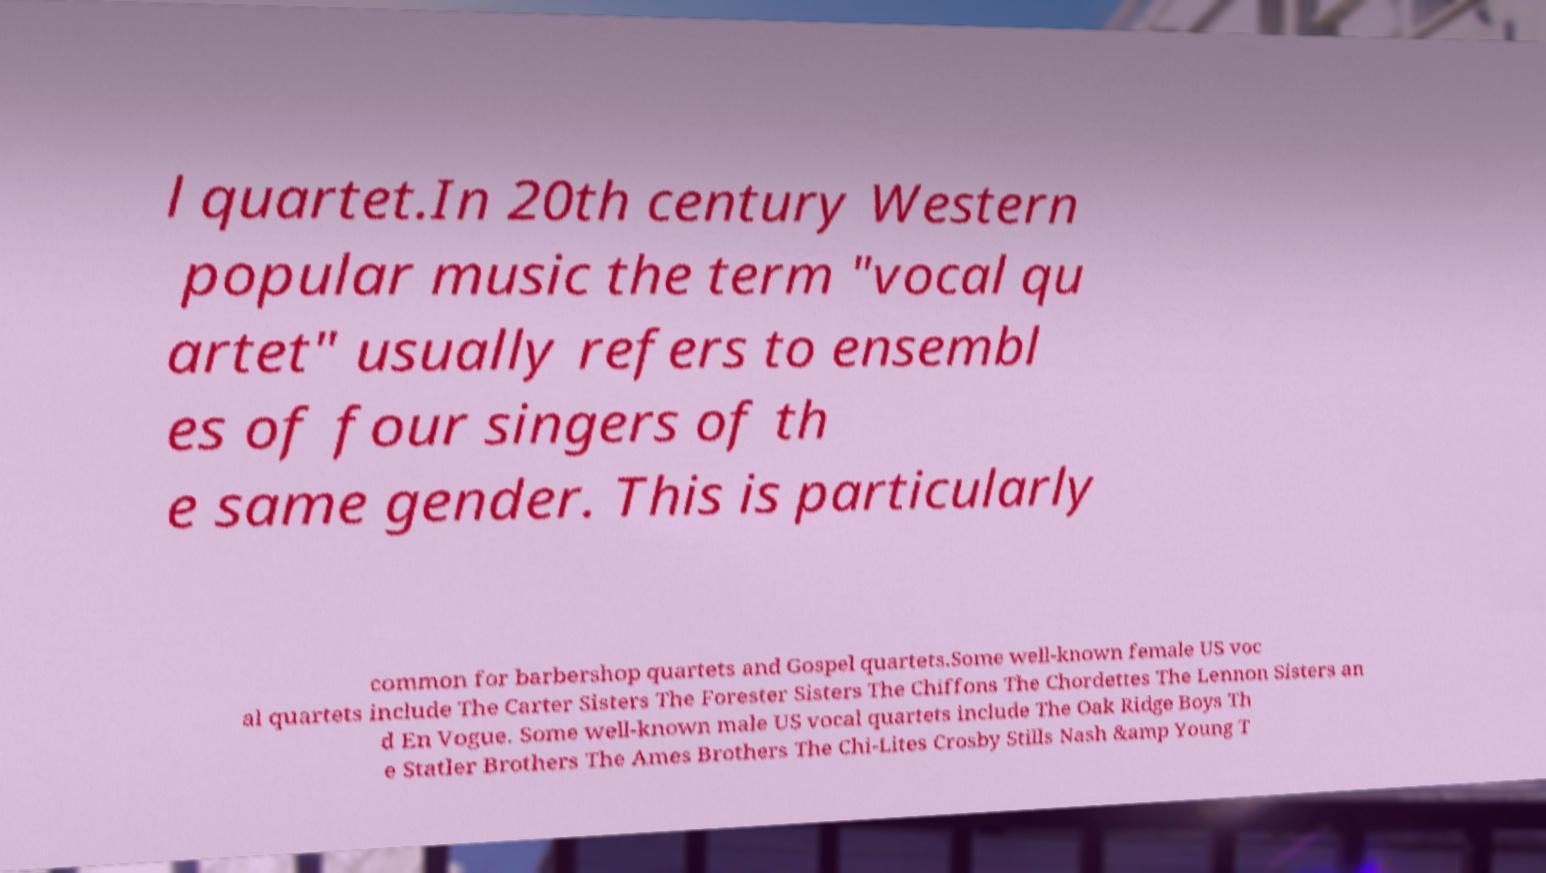Could you extract and type out the text from this image? l quartet.In 20th century Western popular music the term "vocal qu artet" usually refers to ensembl es of four singers of th e same gender. This is particularly common for barbershop quartets and Gospel quartets.Some well-known female US voc al quartets include The Carter Sisters The Forester Sisters The Chiffons The Chordettes The Lennon Sisters an d En Vogue. Some well-known male US vocal quartets include The Oak Ridge Boys Th e Statler Brothers The Ames Brothers The Chi-Lites Crosby Stills Nash &amp Young T 